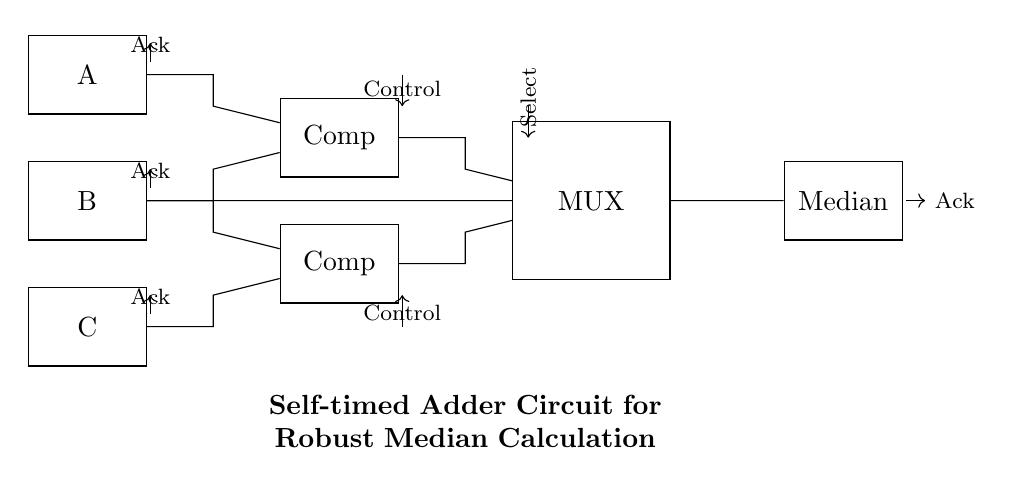What components are present in this circuit? The circuit comprises three registers (A, B, C), two comparators, a multiplexer, and an output register for the median. Each component is distinctly labeled in the diagram.
Answer: three registers, two comparators, a multiplexer, one output register What is the purpose of the multiplexer in this circuit? The multiplexer selects one of several input signals and forwards the selected input into a single line based on the control signals. In this circuit, it helps output the median value after processing the inputs.
Answer: selection of median output How many acknowledgement signals are there? There are three acknowledgment signals from the input registers and one from the output register, as indicated by the arrows pointing towards them in the circuit.
Answer: four acknowledgment signals What controls the selection of inputs to the multiplexer? The inputs to the multiplexer are controlled by the select signal, which determines which of the comparator outputs is forwarded to the output. This is represented by an arrow labeled "Select" pointing to the multiplexer.
Answer: select signal How do the comparators interact with the input registers? Each comparator compares pairs of inputs (A & B for the first comparator, and B & C for the second), generating intermediate results that help the multiplexer decide the final median output based on the comparisons made.
Answer: comparisons of input pairs What type of circuit is this? This is an asynchronous circuit, designed to operate without a global clock signal, where actions are driven by the completion of events and conditions.
Answer: asynchronous circuit What does the control signal do in this circuit? The control signal directs the operation of the comparators and the multiplexer, ensuring they function correctly according to the received input values and timing sequences.
Answer: directs comparator and multiplexer operation 